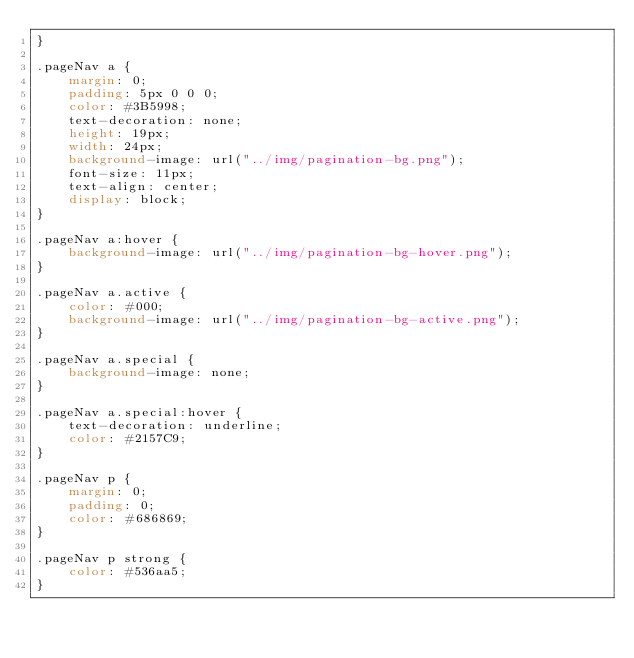<code> <loc_0><loc_0><loc_500><loc_500><_CSS_>}

.pageNav a {
    margin: 0;
    padding: 5px 0 0 0;
    color: #3B5998;
    text-decoration: none;
    height: 19px;
    width: 24px;
    background-image: url("../img/pagination-bg.png");
    font-size: 11px;
    text-align: center;
    display: block;
}

.pageNav a:hover {
    background-image: url("../img/pagination-bg-hover.png");
}

.pageNav a.active {
    color: #000;
    background-image: url("../img/pagination-bg-active.png");
}

.pageNav a.special {
    background-image: none;
}

.pageNav a.special:hover {
    text-decoration: underline;
    color: #2157C9;
}

.pageNav p {
    margin: 0;
    padding: 0;
    color: #686869;
}

.pageNav p strong {
    color: #536aa5;
}</code> 